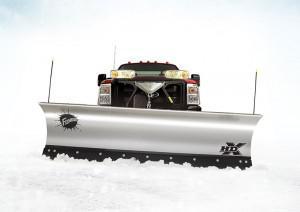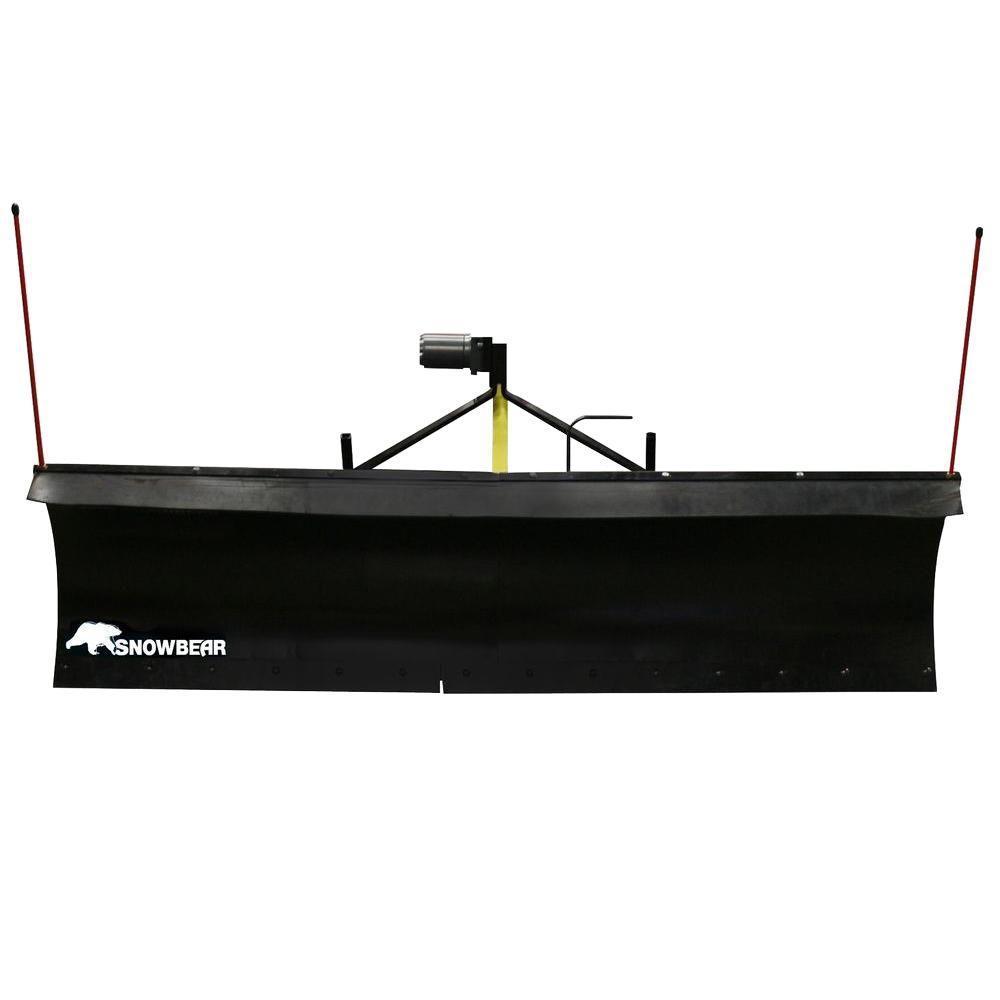The first image is the image on the left, the second image is the image on the right. Considering the images on both sides, is "A white plow is attached to a truck in one of the images." valid? Answer yes or no. Yes. The first image is the image on the left, the second image is the image on the right. Examine the images to the left and right. Is the description "One image shows a pickup truck angled facing to the right with a plow attachment in front." accurate? Answer yes or no. No. 